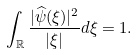<formula> <loc_0><loc_0><loc_500><loc_500>\int _ { \mathbb { R } } \frac { | \widehat { \psi } ( \xi ) | ^ { 2 } } { | \xi | } d \xi = 1 .</formula> 